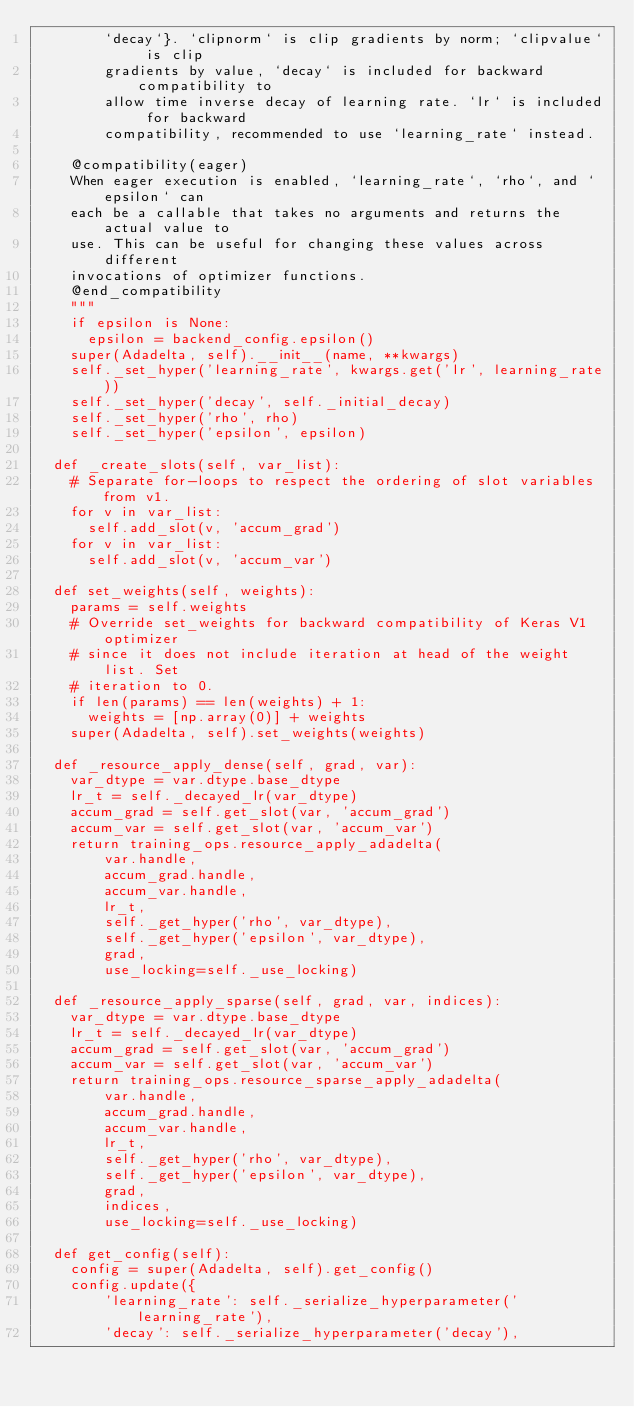Convert code to text. <code><loc_0><loc_0><loc_500><loc_500><_Python_>        `decay`}. `clipnorm` is clip gradients by norm; `clipvalue` is clip
        gradients by value, `decay` is included for backward compatibility to
        allow time inverse decay of learning rate. `lr` is included for backward
        compatibility, recommended to use `learning_rate` instead.

    @compatibility(eager)
    When eager execution is enabled, `learning_rate`, `rho`, and `epsilon` can
    each be a callable that takes no arguments and returns the actual value to
    use. This can be useful for changing these values across different
    invocations of optimizer functions.
    @end_compatibility
    """
    if epsilon is None:
      epsilon = backend_config.epsilon()
    super(Adadelta, self).__init__(name, **kwargs)
    self._set_hyper('learning_rate', kwargs.get('lr', learning_rate))
    self._set_hyper('decay', self._initial_decay)
    self._set_hyper('rho', rho)
    self._set_hyper('epsilon', epsilon)

  def _create_slots(self, var_list):
    # Separate for-loops to respect the ordering of slot variables from v1.
    for v in var_list:
      self.add_slot(v, 'accum_grad')
    for v in var_list:
      self.add_slot(v, 'accum_var')

  def set_weights(self, weights):
    params = self.weights
    # Override set_weights for backward compatibility of Keras V1 optimizer
    # since it does not include iteration at head of the weight list. Set
    # iteration to 0.
    if len(params) == len(weights) + 1:
      weights = [np.array(0)] + weights
    super(Adadelta, self).set_weights(weights)

  def _resource_apply_dense(self, grad, var):
    var_dtype = var.dtype.base_dtype
    lr_t = self._decayed_lr(var_dtype)
    accum_grad = self.get_slot(var, 'accum_grad')
    accum_var = self.get_slot(var, 'accum_var')
    return training_ops.resource_apply_adadelta(
        var.handle,
        accum_grad.handle,
        accum_var.handle,
        lr_t,
        self._get_hyper('rho', var_dtype),
        self._get_hyper('epsilon', var_dtype),
        grad,
        use_locking=self._use_locking)

  def _resource_apply_sparse(self, grad, var, indices):
    var_dtype = var.dtype.base_dtype
    lr_t = self._decayed_lr(var_dtype)
    accum_grad = self.get_slot(var, 'accum_grad')
    accum_var = self.get_slot(var, 'accum_var')
    return training_ops.resource_sparse_apply_adadelta(
        var.handle,
        accum_grad.handle,
        accum_var.handle,
        lr_t,
        self._get_hyper('rho', var_dtype),
        self._get_hyper('epsilon', var_dtype),
        grad,
        indices,
        use_locking=self._use_locking)

  def get_config(self):
    config = super(Adadelta, self).get_config()
    config.update({
        'learning_rate': self._serialize_hyperparameter('learning_rate'),
        'decay': self._serialize_hyperparameter('decay'),</code> 